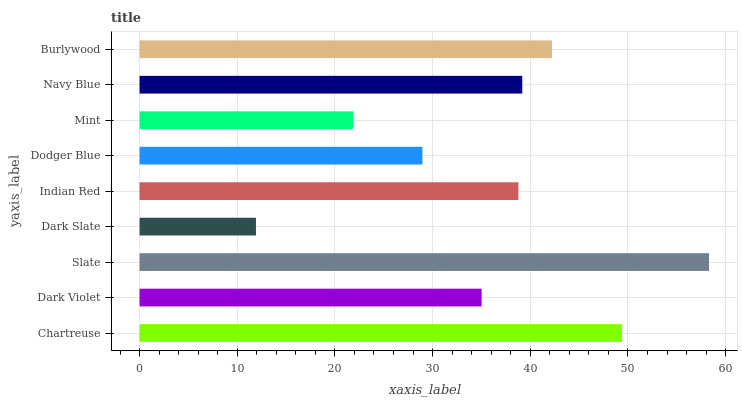Is Dark Slate the minimum?
Answer yes or no. Yes. Is Slate the maximum?
Answer yes or no. Yes. Is Dark Violet the minimum?
Answer yes or no. No. Is Dark Violet the maximum?
Answer yes or no. No. Is Chartreuse greater than Dark Violet?
Answer yes or no. Yes. Is Dark Violet less than Chartreuse?
Answer yes or no. Yes. Is Dark Violet greater than Chartreuse?
Answer yes or no. No. Is Chartreuse less than Dark Violet?
Answer yes or no. No. Is Indian Red the high median?
Answer yes or no. Yes. Is Indian Red the low median?
Answer yes or no. Yes. Is Chartreuse the high median?
Answer yes or no. No. Is Dark Slate the low median?
Answer yes or no. No. 